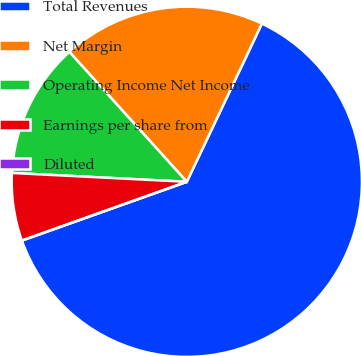Convert chart. <chart><loc_0><loc_0><loc_500><loc_500><pie_chart><fcel>Total Revenues<fcel>Net Margin<fcel>Operating Income Net Income<fcel>Earnings per share from<fcel>Diluted<nl><fcel>62.5%<fcel>18.75%<fcel>12.5%<fcel>6.25%<fcel>0.0%<nl></chart> 